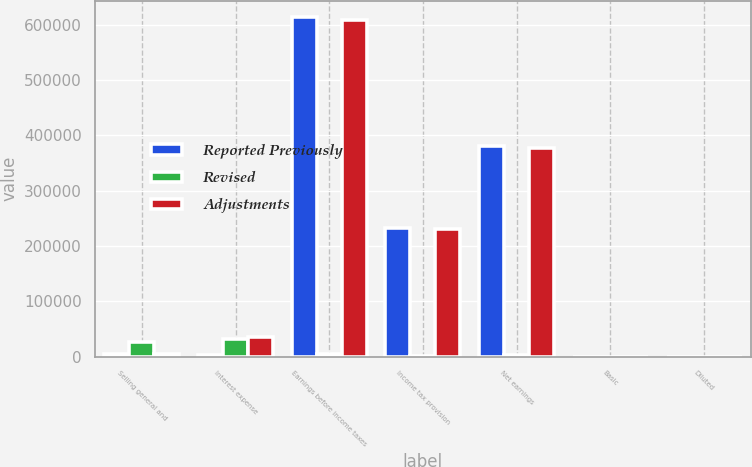Convert chart to OTSL. <chart><loc_0><loc_0><loc_500><loc_500><stacked_bar_chart><ecel><fcel>Selling general and<fcel>Interest expense<fcel>Earnings before income taxes<fcel>Income tax provision<fcel>Net earnings<fcel>Basic<fcel>Diluted<nl><fcel>Reported Previously<fcel>5284<fcel>3110<fcel>613490<fcel>232612<fcel>380878<fcel>1.7<fcel>1.67<nl><fcel>Revised<fcel>26286<fcel>31570<fcel>5284<fcel>1901<fcel>3383<fcel>0.02<fcel>0.02<nl><fcel>Adjustments<fcel>5284<fcel>34680<fcel>608206<fcel>230711<fcel>377495<fcel>1.68<fcel>1.65<nl></chart> 